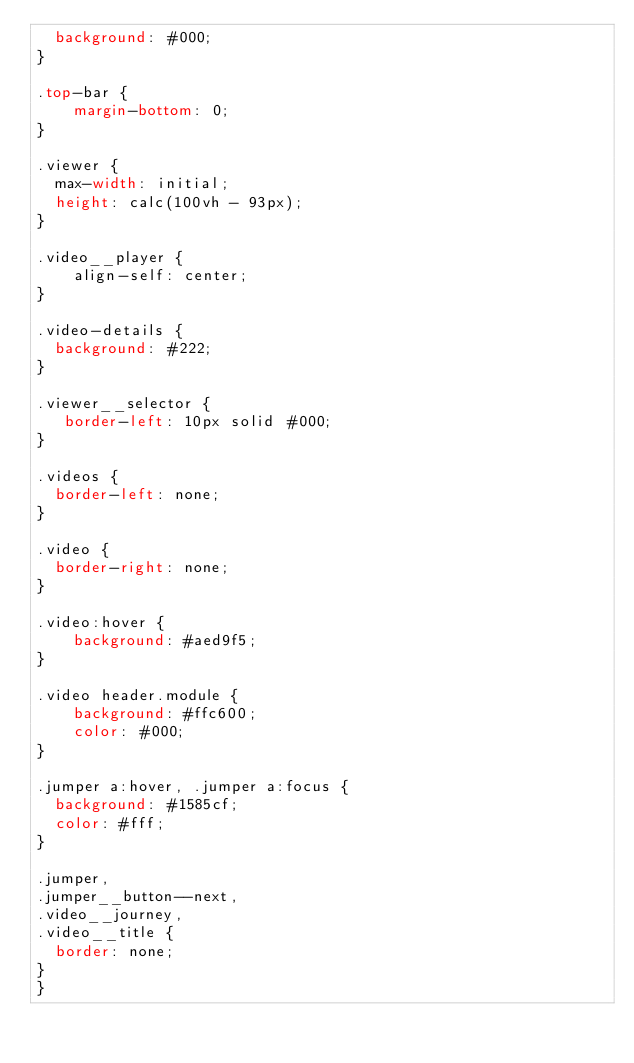Convert code to text. <code><loc_0><loc_0><loc_500><loc_500><_CSS_>  background: #000;
}

.top-bar {
	margin-bottom: 0;
}

.viewer {
  max-width: initial;
  height: calc(100vh - 93px);
}

.video__player {
	align-self: center;
}

.video-details {
  background: #222;
}

.viewer__selector {
   border-left: 10px solid #000;
}

.videos {
  border-left: none;
}

.video {
  border-right: none;
}

.video:hover {
    background: #aed9f5;
}

.video header.module {
    background: #ffc600;
    color: #000;
}

.jumper a:hover, .jumper a:focus {
  background: #1585cf;
  color: #fff;
}

.jumper,
.jumper__button--next,
.video__journey,
.video__title {
  border: none;
}
}</code> 